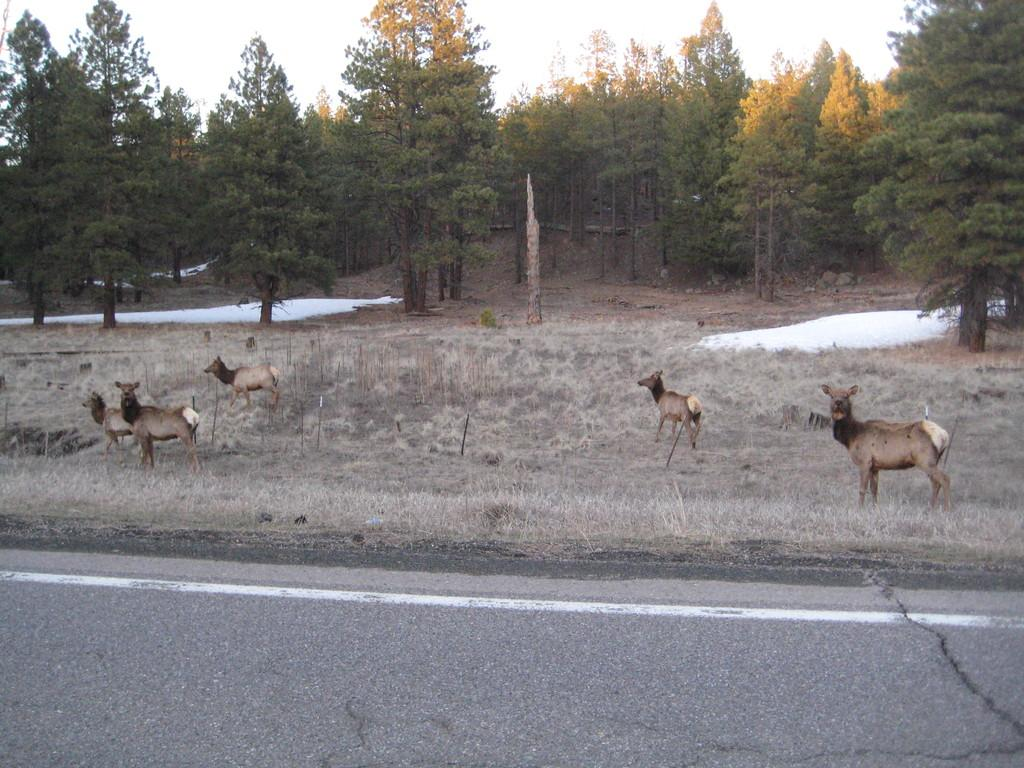What can be seen beside the road in the image? There are years beside the road in the image. What type of natural scenery is visible in the background of the image? There are trees visible in the background of the image. Can you see any bees or goldfish in the image? No, there are no bees or goldfish present in the image. Is there any gold visible in the image? No, there is no gold present in the image. 